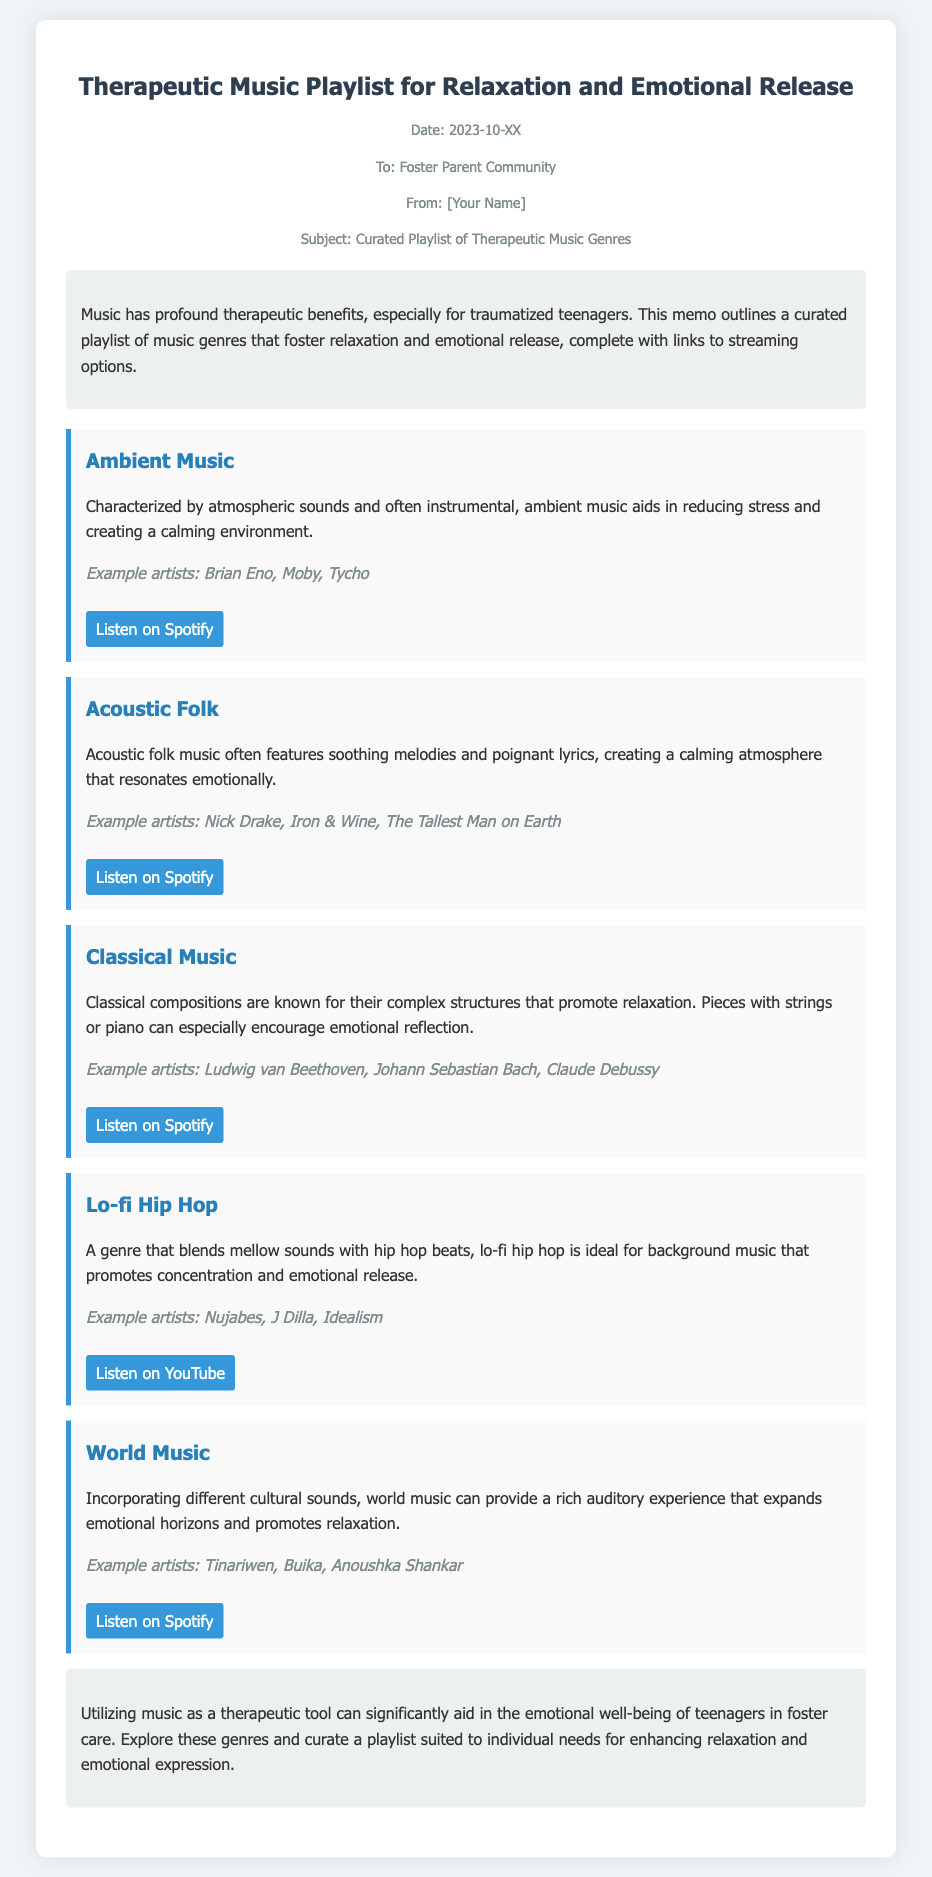What is the title of the memo? The title of the memo is stated at the top of the document, which is about therapeutic music.
Answer: Therapeutic Music Playlist for Relaxation and Emotional Release Who is the memo addressed to? The address section of the memo specifies the audience that it is intended for, which is the community of foster parents.
Answer: Foster Parent Community What genre of music is characterized by atmospheric sounds? One of the included genres in the memo mentions specific characteristics, including atmospheric sounds.
Answer: Ambient Music Which music genre combines mellow sounds with hip hop beats? The memo explains a particular genre that merges mellow sounds with distinctive beats.
Answer: Lo-fi Hip Hop What is the purpose of the curated playlist? The introduction outlines the main goal of the memo, which is to highlight the therapeutic benefits of music.
Answer: Foster relaxation and emotional release How many example artists are listed for Classical Music? Each genre section provides a list of artists; specifically, Classical Music includes a set of three example artists.
Answer: Three What streaming platform is linked for Acoustic Folk music? Each genre in the memo includes links for listening, and this genre specifies a particular streaming service.
Answer: Spotify What is mentioned as a benefit of utilizing music for teenagers in foster care? The conclusion summarizes the emotional benefits such as well-being due to music usage stated in the memo.
Answer: Emotional well-being 